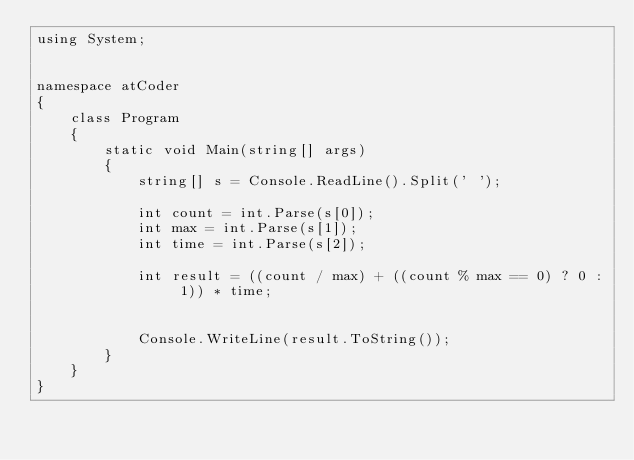<code> <loc_0><loc_0><loc_500><loc_500><_C#_>using System;


namespace atCoder
{
    class Program
    {
        static void Main(string[] args)
        {
            string[] s = Console.ReadLine().Split(' ');

            int count = int.Parse(s[0]);
            int max = int.Parse(s[1]);
            int time = int.Parse(s[2]);

            int result = ((count / max) + ((count % max == 0) ? 0 : 1)) * time;


            Console.WriteLine(result.ToString());
        }
    }
}</code> 